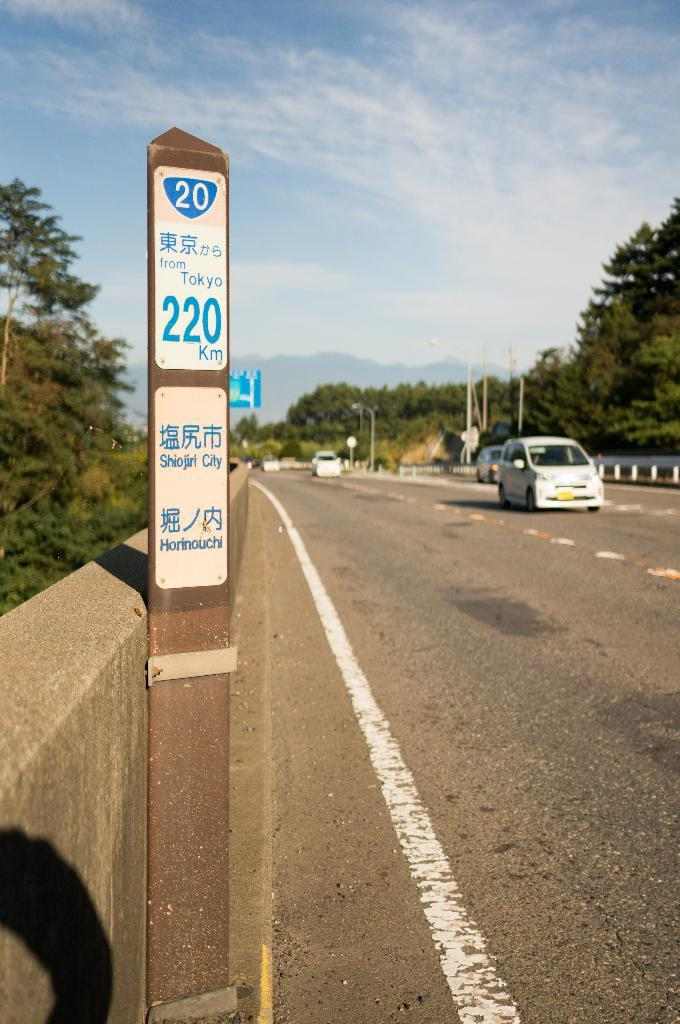<image>
Offer a succinct explanation of the picture presented. A vetical sign shows from Toyko  220 in blue letters. 